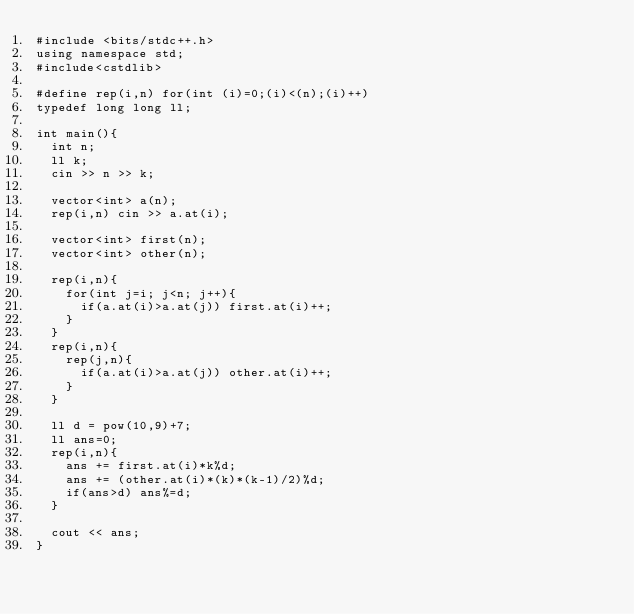<code> <loc_0><loc_0><loc_500><loc_500><_C++_>#include <bits/stdc++.h>
using namespace std;
#include<cstdlib>

#define rep(i,n) for(int (i)=0;(i)<(n);(i)++)
typedef long long ll;

int main(){
  int n;
  ll k;
  cin >> n >> k;

  vector<int> a(n);
  rep(i,n) cin >> a.at(i);

  vector<int> first(n);
  vector<int> other(n);

  rep(i,n){
    for(int j=i; j<n; j++){
      if(a.at(i)>a.at(j)) first.at(i)++;
    }
  }
  rep(i,n){
    rep(j,n){
      if(a.at(i)>a.at(j)) other.at(i)++;
    }
  }

  ll d = pow(10,9)+7;
  ll ans=0;
  rep(i,n){
    ans += first.at(i)*k%d;
    ans += (other.at(i)*(k)*(k-1)/2)%d;
    if(ans>d) ans%=d;
  }

  cout << ans;  
}</code> 